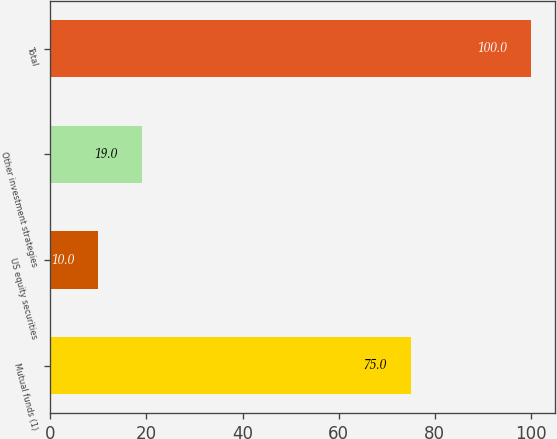Convert chart to OTSL. <chart><loc_0><loc_0><loc_500><loc_500><bar_chart><fcel>Mutual funds (1)<fcel>US equity securities<fcel>Other investment strategies<fcel>Total<nl><fcel>75<fcel>10<fcel>19<fcel>100<nl></chart> 